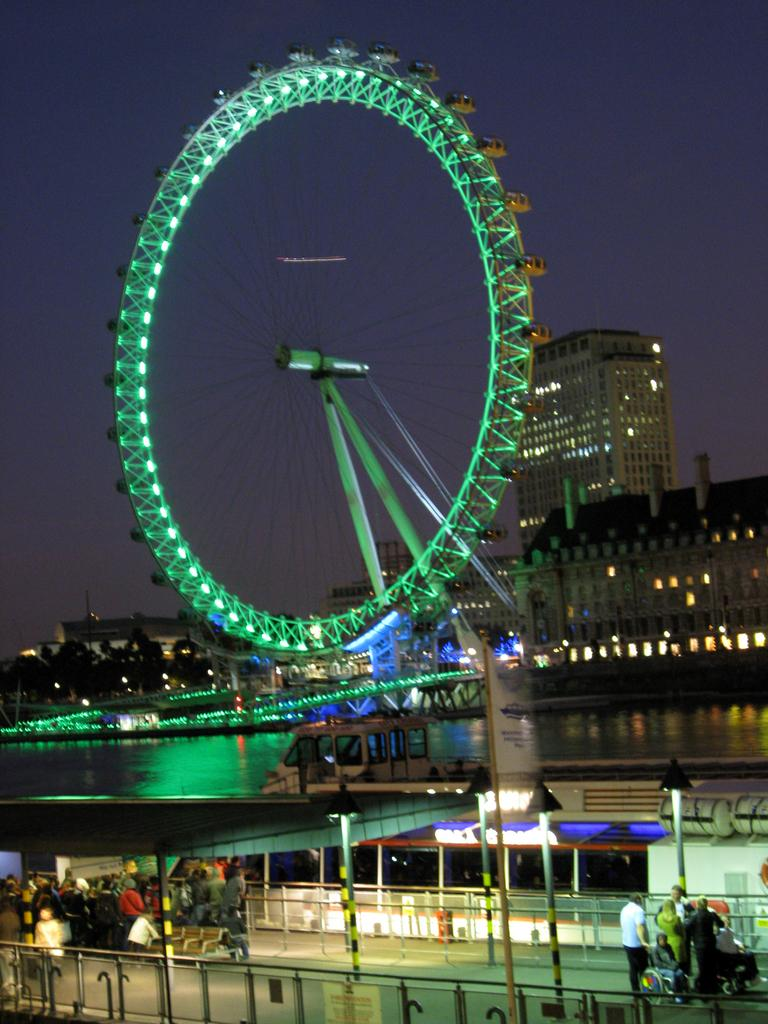What is happening on the ground in the image? There are people on the ground in the image. What can be seen in the background of the image? There are buildings visible in the background of the image. What is visible in the sky in the image? The sky is visible in the background of the image. What type of committee is meeting in the image? There is no committee meeting present in the image. Can you tell me how many beds are visible in the image? There are no beds visible in the image. 